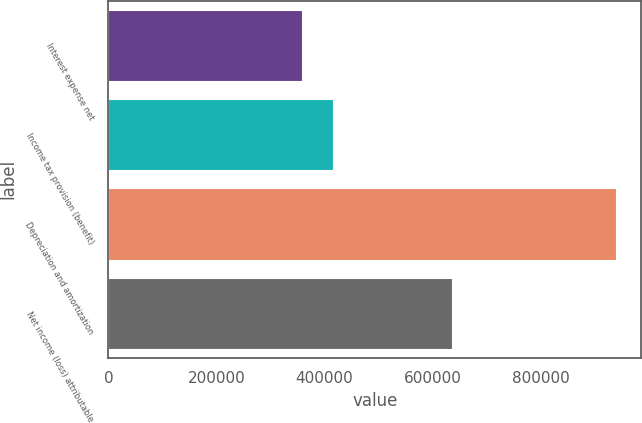Convert chart to OTSL. <chart><loc_0><loc_0><loc_500><loc_500><bar_chart><fcel>Interest expense net<fcel>Income tax provision (benefit)<fcel>Depreciation and amortization<fcel>Net income (loss) attributable<nl><fcel>358391<fcel>416555<fcel>940033<fcel>635545<nl></chart> 